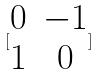<formula> <loc_0><loc_0><loc_500><loc_500>[ \begin{matrix} 0 & - 1 \\ 1 & 0 \end{matrix} ]</formula> 